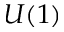<formula> <loc_0><loc_0><loc_500><loc_500>U ( 1 )</formula> 